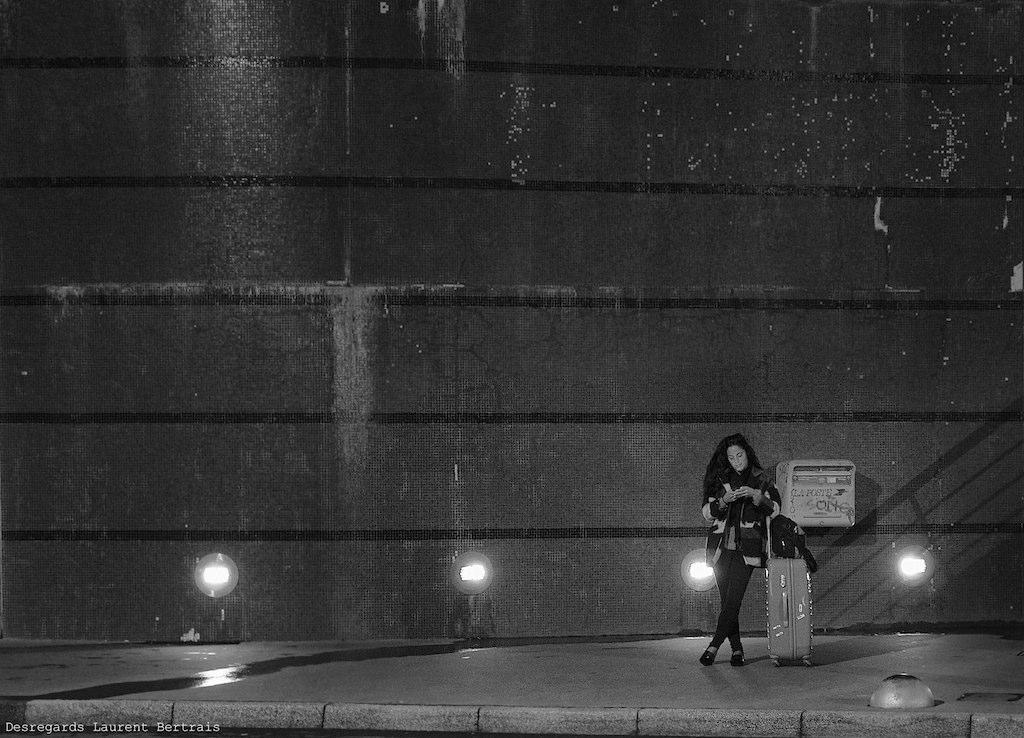Can you describe this image briefly? It is a black and white image, there is a woman standing on a footpath with some luggage and behind the woman there is a wall. 